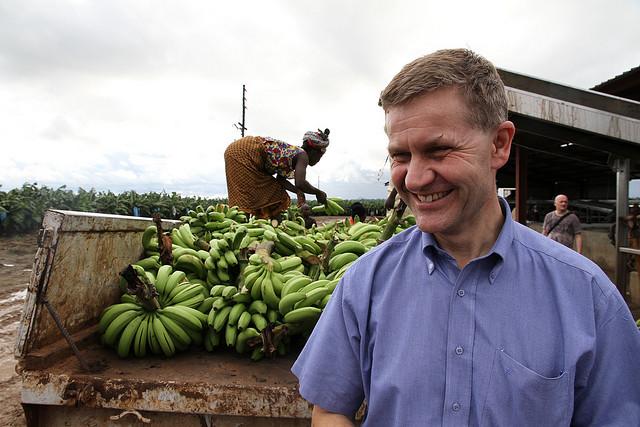Food from which food group is being transported?
Concise answer only. Fruit. Where is the bald man?
Keep it brief. Background. Which person is more likely to be a visitor to this place?
Give a very brief answer. Man in front. What type of sleeves does the man's shirt have?
Give a very brief answer. Short. Does the man have a beard?
Short answer required. No. 